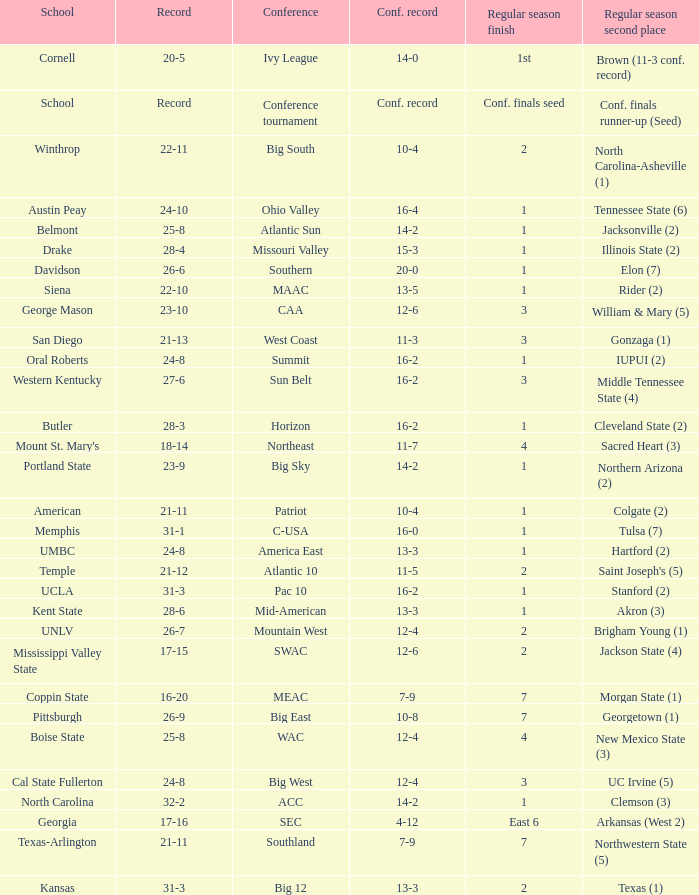What was the overall record of Oral Roberts college? 24-8. 